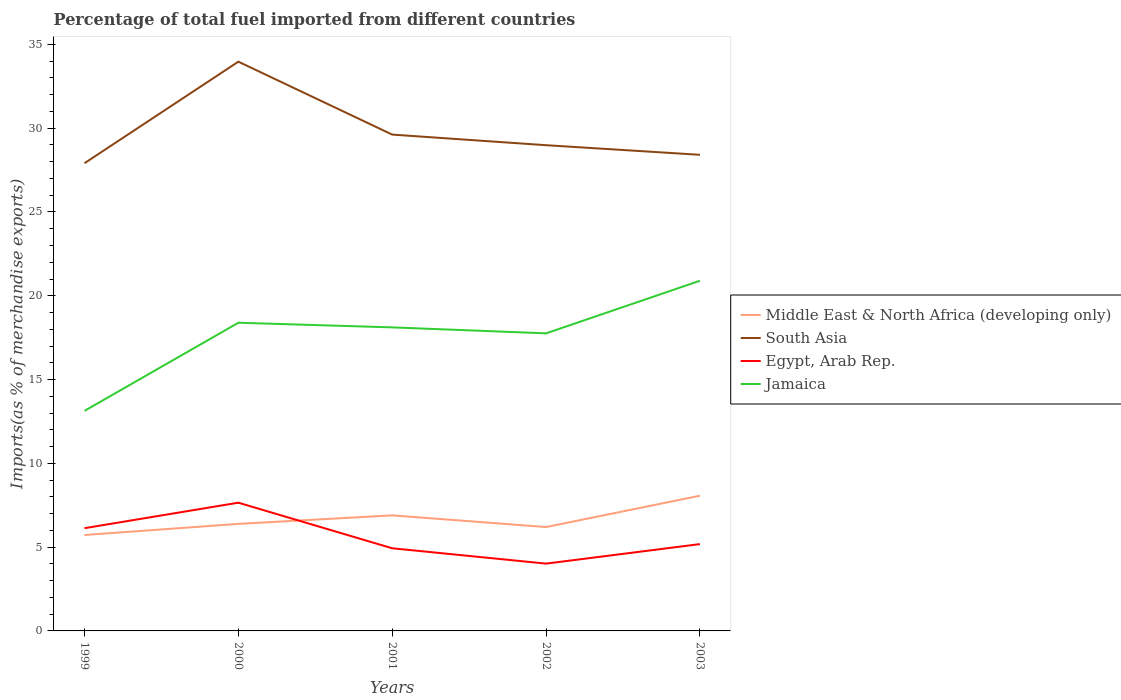How many different coloured lines are there?
Offer a very short reply. 4. Does the line corresponding to Egypt, Arab Rep. intersect with the line corresponding to Middle East & North Africa (developing only)?
Offer a terse response. Yes. Is the number of lines equal to the number of legend labels?
Your answer should be very brief. Yes. Across all years, what is the maximum percentage of imports to different countries in South Asia?
Offer a very short reply. 27.91. In which year was the percentage of imports to different countries in Egypt, Arab Rep. maximum?
Your response must be concise. 2002. What is the total percentage of imports to different countries in Egypt, Arab Rep. in the graph?
Provide a succinct answer. 2.47. What is the difference between the highest and the second highest percentage of imports to different countries in Egypt, Arab Rep.?
Make the answer very short. 3.64. How many years are there in the graph?
Your answer should be very brief. 5. Are the values on the major ticks of Y-axis written in scientific E-notation?
Provide a short and direct response. No. Does the graph contain grids?
Offer a terse response. No. How are the legend labels stacked?
Ensure brevity in your answer.  Vertical. What is the title of the graph?
Make the answer very short. Percentage of total fuel imported from different countries. Does "Hungary" appear as one of the legend labels in the graph?
Keep it short and to the point. No. What is the label or title of the Y-axis?
Your answer should be compact. Imports(as % of merchandise exports). What is the Imports(as % of merchandise exports) in Middle East & North Africa (developing only) in 1999?
Offer a terse response. 5.72. What is the Imports(as % of merchandise exports) of South Asia in 1999?
Offer a very short reply. 27.91. What is the Imports(as % of merchandise exports) in Egypt, Arab Rep. in 1999?
Keep it short and to the point. 6.13. What is the Imports(as % of merchandise exports) of Jamaica in 1999?
Provide a short and direct response. 13.13. What is the Imports(as % of merchandise exports) of Middle East & North Africa (developing only) in 2000?
Make the answer very short. 6.39. What is the Imports(as % of merchandise exports) in South Asia in 2000?
Your answer should be compact. 33.97. What is the Imports(as % of merchandise exports) in Egypt, Arab Rep. in 2000?
Your answer should be compact. 7.65. What is the Imports(as % of merchandise exports) in Jamaica in 2000?
Offer a very short reply. 18.39. What is the Imports(as % of merchandise exports) in Middle East & North Africa (developing only) in 2001?
Make the answer very short. 6.9. What is the Imports(as % of merchandise exports) in South Asia in 2001?
Offer a very short reply. 29.62. What is the Imports(as % of merchandise exports) of Egypt, Arab Rep. in 2001?
Your response must be concise. 4.93. What is the Imports(as % of merchandise exports) in Jamaica in 2001?
Ensure brevity in your answer.  18.11. What is the Imports(as % of merchandise exports) in Middle East & North Africa (developing only) in 2002?
Your response must be concise. 6.2. What is the Imports(as % of merchandise exports) in South Asia in 2002?
Give a very brief answer. 28.99. What is the Imports(as % of merchandise exports) in Egypt, Arab Rep. in 2002?
Your answer should be compact. 4.02. What is the Imports(as % of merchandise exports) of Jamaica in 2002?
Offer a terse response. 17.76. What is the Imports(as % of merchandise exports) in Middle East & North Africa (developing only) in 2003?
Ensure brevity in your answer.  8.07. What is the Imports(as % of merchandise exports) in South Asia in 2003?
Keep it short and to the point. 28.41. What is the Imports(as % of merchandise exports) of Egypt, Arab Rep. in 2003?
Make the answer very short. 5.18. What is the Imports(as % of merchandise exports) in Jamaica in 2003?
Make the answer very short. 20.9. Across all years, what is the maximum Imports(as % of merchandise exports) in Middle East & North Africa (developing only)?
Provide a succinct answer. 8.07. Across all years, what is the maximum Imports(as % of merchandise exports) in South Asia?
Provide a succinct answer. 33.97. Across all years, what is the maximum Imports(as % of merchandise exports) of Egypt, Arab Rep.?
Your answer should be compact. 7.65. Across all years, what is the maximum Imports(as % of merchandise exports) in Jamaica?
Keep it short and to the point. 20.9. Across all years, what is the minimum Imports(as % of merchandise exports) in Middle East & North Africa (developing only)?
Make the answer very short. 5.72. Across all years, what is the minimum Imports(as % of merchandise exports) in South Asia?
Make the answer very short. 27.91. Across all years, what is the minimum Imports(as % of merchandise exports) in Egypt, Arab Rep.?
Provide a succinct answer. 4.02. Across all years, what is the minimum Imports(as % of merchandise exports) of Jamaica?
Your answer should be very brief. 13.13. What is the total Imports(as % of merchandise exports) of Middle East & North Africa (developing only) in the graph?
Your answer should be compact. 33.28. What is the total Imports(as % of merchandise exports) of South Asia in the graph?
Your answer should be very brief. 148.9. What is the total Imports(as % of merchandise exports) of Egypt, Arab Rep. in the graph?
Ensure brevity in your answer.  27.91. What is the total Imports(as % of merchandise exports) of Jamaica in the graph?
Provide a succinct answer. 88.29. What is the difference between the Imports(as % of merchandise exports) in Middle East & North Africa (developing only) in 1999 and that in 2000?
Offer a terse response. -0.66. What is the difference between the Imports(as % of merchandise exports) of South Asia in 1999 and that in 2000?
Ensure brevity in your answer.  -6.06. What is the difference between the Imports(as % of merchandise exports) of Egypt, Arab Rep. in 1999 and that in 2000?
Your response must be concise. -1.52. What is the difference between the Imports(as % of merchandise exports) in Jamaica in 1999 and that in 2000?
Give a very brief answer. -5.26. What is the difference between the Imports(as % of merchandise exports) of Middle East & North Africa (developing only) in 1999 and that in 2001?
Your answer should be very brief. -1.17. What is the difference between the Imports(as % of merchandise exports) of South Asia in 1999 and that in 2001?
Your answer should be compact. -1.71. What is the difference between the Imports(as % of merchandise exports) of Egypt, Arab Rep. in 1999 and that in 2001?
Make the answer very short. 1.2. What is the difference between the Imports(as % of merchandise exports) of Jamaica in 1999 and that in 2001?
Your response must be concise. -4.98. What is the difference between the Imports(as % of merchandise exports) of Middle East & North Africa (developing only) in 1999 and that in 2002?
Provide a short and direct response. -0.48. What is the difference between the Imports(as % of merchandise exports) in South Asia in 1999 and that in 2002?
Provide a short and direct response. -1.08. What is the difference between the Imports(as % of merchandise exports) of Egypt, Arab Rep. in 1999 and that in 2002?
Give a very brief answer. 2.11. What is the difference between the Imports(as % of merchandise exports) in Jamaica in 1999 and that in 2002?
Your answer should be compact. -4.63. What is the difference between the Imports(as % of merchandise exports) of Middle East & North Africa (developing only) in 1999 and that in 2003?
Keep it short and to the point. -2.35. What is the difference between the Imports(as % of merchandise exports) of South Asia in 1999 and that in 2003?
Ensure brevity in your answer.  -0.5. What is the difference between the Imports(as % of merchandise exports) in Egypt, Arab Rep. in 1999 and that in 2003?
Provide a succinct answer. 0.95. What is the difference between the Imports(as % of merchandise exports) of Jamaica in 1999 and that in 2003?
Your answer should be very brief. -7.76. What is the difference between the Imports(as % of merchandise exports) of Middle East & North Africa (developing only) in 2000 and that in 2001?
Keep it short and to the point. -0.51. What is the difference between the Imports(as % of merchandise exports) of South Asia in 2000 and that in 2001?
Offer a terse response. 4.35. What is the difference between the Imports(as % of merchandise exports) in Egypt, Arab Rep. in 2000 and that in 2001?
Provide a short and direct response. 2.72. What is the difference between the Imports(as % of merchandise exports) of Jamaica in 2000 and that in 2001?
Make the answer very short. 0.28. What is the difference between the Imports(as % of merchandise exports) in Middle East & North Africa (developing only) in 2000 and that in 2002?
Give a very brief answer. 0.19. What is the difference between the Imports(as % of merchandise exports) of South Asia in 2000 and that in 2002?
Offer a terse response. 4.98. What is the difference between the Imports(as % of merchandise exports) in Egypt, Arab Rep. in 2000 and that in 2002?
Offer a terse response. 3.64. What is the difference between the Imports(as % of merchandise exports) of Jamaica in 2000 and that in 2002?
Your response must be concise. 0.63. What is the difference between the Imports(as % of merchandise exports) of Middle East & North Africa (developing only) in 2000 and that in 2003?
Make the answer very short. -1.68. What is the difference between the Imports(as % of merchandise exports) in South Asia in 2000 and that in 2003?
Make the answer very short. 5.56. What is the difference between the Imports(as % of merchandise exports) in Egypt, Arab Rep. in 2000 and that in 2003?
Your answer should be very brief. 2.47. What is the difference between the Imports(as % of merchandise exports) of Jamaica in 2000 and that in 2003?
Provide a succinct answer. -2.51. What is the difference between the Imports(as % of merchandise exports) in Middle East & North Africa (developing only) in 2001 and that in 2002?
Offer a very short reply. 0.7. What is the difference between the Imports(as % of merchandise exports) in South Asia in 2001 and that in 2002?
Give a very brief answer. 0.63. What is the difference between the Imports(as % of merchandise exports) of Egypt, Arab Rep. in 2001 and that in 2002?
Provide a succinct answer. 0.92. What is the difference between the Imports(as % of merchandise exports) in Jamaica in 2001 and that in 2002?
Make the answer very short. 0.36. What is the difference between the Imports(as % of merchandise exports) in Middle East & North Africa (developing only) in 2001 and that in 2003?
Provide a short and direct response. -1.17. What is the difference between the Imports(as % of merchandise exports) of South Asia in 2001 and that in 2003?
Your answer should be compact. 1.21. What is the difference between the Imports(as % of merchandise exports) of Egypt, Arab Rep. in 2001 and that in 2003?
Keep it short and to the point. -0.25. What is the difference between the Imports(as % of merchandise exports) of Jamaica in 2001 and that in 2003?
Provide a succinct answer. -2.78. What is the difference between the Imports(as % of merchandise exports) of Middle East & North Africa (developing only) in 2002 and that in 2003?
Provide a succinct answer. -1.87. What is the difference between the Imports(as % of merchandise exports) of South Asia in 2002 and that in 2003?
Your answer should be compact. 0.57. What is the difference between the Imports(as % of merchandise exports) in Egypt, Arab Rep. in 2002 and that in 2003?
Your response must be concise. -1.16. What is the difference between the Imports(as % of merchandise exports) in Jamaica in 2002 and that in 2003?
Your response must be concise. -3.14. What is the difference between the Imports(as % of merchandise exports) in Middle East & North Africa (developing only) in 1999 and the Imports(as % of merchandise exports) in South Asia in 2000?
Ensure brevity in your answer.  -28.25. What is the difference between the Imports(as % of merchandise exports) in Middle East & North Africa (developing only) in 1999 and the Imports(as % of merchandise exports) in Egypt, Arab Rep. in 2000?
Give a very brief answer. -1.93. What is the difference between the Imports(as % of merchandise exports) in Middle East & North Africa (developing only) in 1999 and the Imports(as % of merchandise exports) in Jamaica in 2000?
Give a very brief answer. -12.67. What is the difference between the Imports(as % of merchandise exports) of South Asia in 1999 and the Imports(as % of merchandise exports) of Egypt, Arab Rep. in 2000?
Make the answer very short. 20.26. What is the difference between the Imports(as % of merchandise exports) in South Asia in 1999 and the Imports(as % of merchandise exports) in Jamaica in 2000?
Your response must be concise. 9.52. What is the difference between the Imports(as % of merchandise exports) in Egypt, Arab Rep. in 1999 and the Imports(as % of merchandise exports) in Jamaica in 2000?
Your response must be concise. -12.26. What is the difference between the Imports(as % of merchandise exports) in Middle East & North Africa (developing only) in 1999 and the Imports(as % of merchandise exports) in South Asia in 2001?
Provide a short and direct response. -23.9. What is the difference between the Imports(as % of merchandise exports) in Middle East & North Africa (developing only) in 1999 and the Imports(as % of merchandise exports) in Egypt, Arab Rep. in 2001?
Keep it short and to the point. 0.79. What is the difference between the Imports(as % of merchandise exports) in Middle East & North Africa (developing only) in 1999 and the Imports(as % of merchandise exports) in Jamaica in 2001?
Provide a succinct answer. -12.39. What is the difference between the Imports(as % of merchandise exports) in South Asia in 1999 and the Imports(as % of merchandise exports) in Egypt, Arab Rep. in 2001?
Provide a short and direct response. 22.98. What is the difference between the Imports(as % of merchandise exports) of South Asia in 1999 and the Imports(as % of merchandise exports) of Jamaica in 2001?
Keep it short and to the point. 9.8. What is the difference between the Imports(as % of merchandise exports) of Egypt, Arab Rep. in 1999 and the Imports(as % of merchandise exports) of Jamaica in 2001?
Provide a short and direct response. -11.98. What is the difference between the Imports(as % of merchandise exports) of Middle East & North Africa (developing only) in 1999 and the Imports(as % of merchandise exports) of South Asia in 2002?
Your response must be concise. -23.26. What is the difference between the Imports(as % of merchandise exports) in Middle East & North Africa (developing only) in 1999 and the Imports(as % of merchandise exports) in Egypt, Arab Rep. in 2002?
Your response must be concise. 1.71. What is the difference between the Imports(as % of merchandise exports) in Middle East & North Africa (developing only) in 1999 and the Imports(as % of merchandise exports) in Jamaica in 2002?
Your answer should be compact. -12.03. What is the difference between the Imports(as % of merchandise exports) of South Asia in 1999 and the Imports(as % of merchandise exports) of Egypt, Arab Rep. in 2002?
Offer a very short reply. 23.89. What is the difference between the Imports(as % of merchandise exports) in South Asia in 1999 and the Imports(as % of merchandise exports) in Jamaica in 2002?
Provide a short and direct response. 10.15. What is the difference between the Imports(as % of merchandise exports) in Egypt, Arab Rep. in 1999 and the Imports(as % of merchandise exports) in Jamaica in 2002?
Your response must be concise. -11.63. What is the difference between the Imports(as % of merchandise exports) in Middle East & North Africa (developing only) in 1999 and the Imports(as % of merchandise exports) in South Asia in 2003?
Ensure brevity in your answer.  -22.69. What is the difference between the Imports(as % of merchandise exports) of Middle East & North Africa (developing only) in 1999 and the Imports(as % of merchandise exports) of Egypt, Arab Rep. in 2003?
Make the answer very short. 0.54. What is the difference between the Imports(as % of merchandise exports) in Middle East & North Africa (developing only) in 1999 and the Imports(as % of merchandise exports) in Jamaica in 2003?
Offer a very short reply. -15.17. What is the difference between the Imports(as % of merchandise exports) of South Asia in 1999 and the Imports(as % of merchandise exports) of Egypt, Arab Rep. in 2003?
Your response must be concise. 22.73. What is the difference between the Imports(as % of merchandise exports) in South Asia in 1999 and the Imports(as % of merchandise exports) in Jamaica in 2003?
Offer a very short reply. 7.01. What is the difference between the Imports(as % of merchandise exports) of Egypt, Arab Rep. in 1999 and the Imports(as % of merchandise exports) of Jamaica in 2003?
Your answer should be compact. -14.77. What is the difference between the Imports(as % of merchandise exports) of Middle East & North Africa (developing only) in 2000 and the Imports(as % of merchandise exports) of South Asia in 2001?
Offer a very short reply. -23.23. What is the difference between the Imports(as % of merchandise exports) in Middle East & North Africa (developing only) in 2000 and the Imports(as % of merchandise exports) in Egypt, Arab Rep. in 2001?
Provide a succinct answer. 1.46. What is the difference between the Imports(as % of merchandise exports) in Middle East & North Africa (developing only) in 2000 and the Imports(as % of merchandise exports) in Jamaica in 2001?
Give a very brief answer. -11.73. What is the difference between the Imports(as % of merchandise exports) of South Asia in 2000 and the Imports(as % of merchandise exports) of Egypt, Arab Rep. in 2001?
Offer a terse response. 29.04. What is the difference between the Imports(as % of merchandise exports) of South Asia in 2000 and the Imports(as % of merchandise exports) of Jamaica in 2001?
Your response must be concise. 15.86. What is the difference between the Imports(as % of merchandise exports) in Egypt, Arab Rep. in 2000 and the Imports(as % of merchandise exports) in Jamaica in 2001?
Your answer should be very brief. -10.46. What is the difference between the Imports(as % of merchandise exports) in Middle East & North Africa (developing only) in 2000 and the Imports(as % of merchandise exports) in South Asia in 2002?
Ensure brevity in your answer.  -22.6. What is the difference between the Imports(as % of merchandise exports) of Middle East & North Africa (developing only) in 2000 and the Imports(as % of merchandise exports) of Egypt, Arab Rep. in 2002?
Offer a very short reply. 2.37. What is the difference between the Imports(as % of merchandise exports) of Middle East & North Africa (developing only) in 2000 and the Imports(as % of merchandise exports) of Jamaica in 2002?
Make the answer very short. -11.37. What is the difference between the Imports(as % of merchandise exports) of South Asia in 2000 and the Imports(as % of merchandise exports) of Egypt, Arab Rep. in 2002?
Give a very brief answer. 29.95. What is the difference between the Imports(as % of merchandise exports) in South Asia in 2000 and the Imports(as % of merchandise exports) in Jamaica in 2002?
Offer a terse response. 16.21. What is the difference between the Imports(as % of merchandise exports) of Egypt, Arab Rep. in 2000 and the Imports(as % of merchandise exports) of Jamaica in 2002?
Your answer should be very brief. -10.11. What is the difference between the Imports(as % of merchandise exports) in Middle East & North Africa (developing only) in 2000 and the Imports(as % of merchandise exports) in South Asia in 2003?
Offer a very short reply. -22.02. What is the difference between the Imports(as % of merchandise exports) in Middle East & North Africa (developing only) in 2000 and the Imports(as % of merchandise exports) in Egypt, Arab Rep. in 2003?
Keep it short and to the point. 1.21. What is the difference between the Imports(as % of merchandise exports) in Middle East & North Africa (developing only) in 2000 and the Imports(as % of merchandise exports) in Jamaica in 2003?
Provide a short and direct response. -14.51. What is the difference between the Imports(as % of merchandise exports) of South Asia in 2000 and the Imports(as % of merchandise exports) of Egypt, Arab Rep. in 2003?
Keep it short and to the point. 28.79. What is the difference between the Imports(as % of merchandise exports) in South Asia in 2000 and the Imports(as % of merchandise exports) in Jamaica in 2003?
Your answer should be compact. 13.07. What is the difference between the Imports(as % of merchandise exports) of Egypt, Arab Rep. in 2000 and the Imports(as % of merchandise exports) of Jamaica in 2003?
Your response must be concise. -13.24. What is the difference between the Imports(as % of merchandise exports) of Middle East & North Africa (developing only) in 2001 and the Imports(as % of merchandise exports) of South Asia in 2002?
Offer a terse response. -22.09. What is the difference between the Imports(as % of merchandise exports) of Middle East & North Africa (developing only) in 2001 and the Imports(as % of merchandise exports) of Egypt, Arab Rep. in 2002?
Provide a short and direct response. 2.88. What is the difference between the Imports(as % of merchandise exports) in Middle East & North Africa (developing only) in 2001 and the Imports(as % of merchandise exports) in Jamaica in 2002?
Provide a succinct answer. -10.86. What is the difference between the Imports(as % of merchandise exports) of South Asia in 2001 and the Imports(as % of merchandise exports) of Egypt, Arab Rep. in 2002?
Offer a very short reply. 25.6. What is the difference between the Imports(as % of merchandise exports) in South Asia in 2001 and the Imports(as % of merchandise exports) in Jamaica in 2002?
Offer a very short reply. 11.86. What is the difference between the Imports(as % of merchandise exports) of Egypt, Arab Rep. in 2001 and the Imports(as % of merchandise exports) of Jamaica in 2002?
Provide a succinct answer. -12.83. What is the difference between the Imports(as % of merchandise exports) in Middle East & North Africa (developing only) in 2001 and the Imports(as % of merchandise exports) in South Asia in 2003?
Make the answer very short. -21.52. What is the difference between the Imports(as % of merchandise exports) of Middle East & North Africa (developing only) in 2001 and the Imports(as % of merchandise exports) of Egypt, Arab Rep. in 2003?
Provide a succinct answer. 1.72. What is the difference between the Imports(as % of merchandise exports) of Middle East & North Africa (developing only) in 2001 and the Imports(as % of merchandise exports) of Jamaica in 2003?
Ensure brevity in your answer.  -14. What is the difference between the Imports(as % of merchandise exports) in South Asia in 2001 and the Imports(as % of merchandise exports) in Egypt, Arab Rep. in 2003?
Provide a succinct answer. 24.44. What is the difference between the Imports(as % of merchandise exports) of South Asia in 2001 and the Imports(as % of merchandise exports) of Jamaica in 2003?
Make the answer very short. 8.72. What is the difference between the Imports(as % of merchandise exports) in Egypt, Arab Rep. in 2001 and the Imports(as % of merchandise exports) in Jamaica in 2003?
Your answer should be compact. -15.96. What is the difference between the Imports(as % of merchandise exports) in Middle East & North Africa (developing only) in 2002 and the Imports(as % of merchandise exports) in South Asia in 2003?
Offer a terse response. -22.21. What is the difference between the Imports(as % of merchandise exports) in Middle East & North Africa (developing only) in 2002 and the Imports(as % of merchandise exports) in Egypt, Arab Rep. in 2003?
Your answer should be compact. 1.02. What is the difference between the Imports(as % of merchandise exports) in Middle East & North Africa (developing only) in 2002 and the Imports(as % of merchandise exports) in Jamaica in 2003?
Ensure brevity in your answer.  -14.7. What is the difference between the Imports(as % of merchandise exports) of South Asia in 2002 and the Imports(as % of merchandise exports) of Egypt, Arab Rep. in 2003?
Give a very brief answer. 23.8. What is the difference between the Imports(as % of merchandise exports) of South Asia in 2002 and the Imports(as % of merchandise exports) of Jamaica in 2003?
Your answer should be compact. 8.09. What is the difference between the Imports(as % of merchandise exports) of Egypt, Arab Rep. in 2002 and the Imports(as % of merchandise exports) of Jamaica in 2003?
Provide a succinct answer. -16.88. What is the average Imports(as % of merchandise exports) of Middle East & North Africa (developing only) per year?
Make the answer very short. 6.66. What is the average Imports(as % of merchandise exports) in South Asia per year?
Ensure brevity in your answer.  29.78. What is the average Imports(as % of merchandise exports) of Egypt, Arab Rep. per year?
Keep it short and to the point. 5.58. What is the average Imports(as % of merchandise exports) of Jamaica per year?
Make the answer very short. 17.66. In the year 1999, what is the difference between the Imports(as % of merchandise exports) in Middle East & North Africa (developing only) and Imports(as % of merchandise exports) in South Asia?
Make the answer very short. -22.19. In the year 1999, what is the difference between the Imports(as % of merchandise exports) of Middle East & North Africa (developing only) and Imports(as % of merchandise exports) of Egypt, Arab Rep.?
Keep it short and to the point. -0.41. In the year 1999, what is the difference between the Imports(as % of merchandise exports) in Middle East & North Africa (developing only) and Imports(as % of merchandise exports) in Jamaica?
Give a very brief answer. -7.41. In the year 1999, what is the difference between the Imports(as % of merchandise exports) in South Asia and Imports(as % of merchandise exports) in Egypt, Arab Rep.?
Provide a short and direct response. 21.78. In the year 1999, what is the difference between the Imports(as % of merchandise exports) in South Asia and Imports(as % of merchandise exports) in Jamaica?
Your answer should be very brief. 14.78. In the year 1999, what is the difference between the Imports(as % of merchandise exports) of Egypt, Arab Rep. and Imports(as % of merchandise exports) of Jamaica?
Give a very brief answer. -7. In the year 2000, what is the difference between the Imports(as % of merchandise exports) of Middle East & North Africa (developing only) and Imports(as % of merchandise exports) of South Asia?
Provide a succinct answer. -27.58. In the year 2000, what is the difference between the Imports(as % of merchandise exports) of Middle East & North Africa (developing only) and Imports(as % of merchandise exports) of Egypt, Arab Rep.?
Your answer should be compact. -1.26. In the year 2000, what is the difference between the Imports(as % of merchandise exports) of Middle East & North Africa (developing only) and Imports(as % of merchandise exports) of Jamaica?
Make the answer very short. -12. In the year 2000, what is the difference between the Imports(as % of merchandise exports) in South Asia and Imports(as % of merchandise exports) in Egypt, Arab Rep.?
Your response must be concise. 26.32. In the year 2000, what is the difference between the Imports(as % of merchandise exports) of South Asia and Imports(as % of merchandise exports) of Jamaica?
Provide a short and direct response. 15.58. In the year 2000, what is the difference between the Imports(as % of merchandise exports) of Egypt, Arab Rep. and Imports(as % of merchandise exports) of Jamaica?
Your answer should be very brief. -10.74. In the year 2001, what is the difference between the Imports(as % of merchandise exports) in Middle East & North Africa (developing only) and Imports(as % of merchandise exports) in South Asia?
Your response must be concise. -22.72. In the year 2001, what is the difference between the Imports(as % of merchandise exports) in Middle East & North Africa (developing only) and Imports(as % of merchandise exports) in Egypt, Arab Rep.?
Offer a terse response. 1.96. In the year 2001, what is the difference between the Imports(as % of merchandise exports) in Middle East & North Africa (developing only) and Imports(as % of merchandise exports) in Jamaica?
Your answer should be very brief. -11.22. In the year 2001, what is the difference between the Imports(as % of merchandise exports) in South Asia and Imports(as % of merchandise exports) in Egypt, Arab Rep.?
Your response must be concise. 24.69. In the year 2001, what is the difference between the Imports(as % of merchandise exports) in South Asia and Imports(as % of merchandise exports) in Jamaica?
Give a very brief answer. 11.5. In the year 2001, what is the difference between the Imports(as % of merchandise exports) of Egypt, Arab Rep. and Imports(as % of merchandise exports) of Jamaica?
Ensure brevity in your answer.  -13.18. In the year 2002, what is the difference between the Imports(as % of merchandise exports) of Middle East & North Africa (developing only) and Imports(as % of merchandise exports) of South Asia?
Offer a very short reply. -22.79. In the year 2002, what is the difference between the Imports(as % of merchandise exports) in Middle East & North Africa (developing only) and Imports(as % of merchandise exports) in Egypt, Arab Rep.?
Your answer should be very brief. 2.18. In the year 2002, what is the difference between the Imports(as % of merchandise exports) of Middle East & North Africa (developing only) and Imports(as % of merchandise exports) of Jamaica?
Give a very brief answer. -11.56. In the year 2002, what is the difference between the Imports(as % of merchandise exports) in South Asia and Imports(as % of merchandise exports) in Egypt, Arab Rep.?
Make the answer very short. 24.97. In the year 2002, what is the difference between the Imports(as % of merchandise exports) in South Asia and Imports(as % of merchandise exports) in Jamaica?
Your answer should be compact. 11.23. In the year 2002, what is the difference between the Imports(as % of merchandise exports) of Egypt, Arab Rep. and Imports(as % of merchandise exports) of Jamaica?
Provide a short and direct response. -13.74. In the year 2003, what is the difference between the Imports(as % of merchandise exports) of Middle East & North Africa (developing only) and Imports(as % of merchandise exports) of South Asia?
Your response must be concise. -20.34. In the year 2003, what is the difference between the Imports(as % of merchandise exports) of Middle East & North Africa (developing only) and Imports(as % of merchandise exports) of Egypt, Arab Rep.?
Your answer should be very brief. 2.89. In the year 2003, what is the difference between the Imports(as % of merchandise exports) of Middle East & North Africa (developing only) and Imports(as % of merchandise exports) of Jamaica?
Provide a short and direct response. -12.83. In the year 2003, what is the difference between the Imports(as % of merchandise exports) of South Asia and Imports(as % of merchandise exports) of Egypt, Arab Rep.?
Your answer should be compact. 23.23. In the year 2003, what is the difference between the Imports(as % of merchandise exports) in South Asia and Imports(as % of merchandise exports) in Jamaica?
Provide a succinct answer. 7.52. In the year 2003, what is the difference between the Imports(as % of merchandise exports) in Egypt, Arab Rep. and Imports(as % of merchandise exports) in Jamaica?
Offer a terse response. -15.71. What is the ratio of the Imports(as % of merchandise exports) of Middle East & North Africa (developing only) in 1999 to that in 2000?
Offer a terse response. 0.9. What is the ratio of the Imports(as % of merchandise exports) in South Asia in 1999 to that in 2000?
Your answer should be compact. 0.82. What is the ratio of the Imports(as % of merchandise exports) in Egypt, Arab Rep. in 1999 to that in 2000?
Offer a terse response. 0.8. What is the ratio of the Imports(as % of merchandise exports) in Jamaica in 1999 to that in 2000?
Provide a succinct answer. 0.71. What is the ratio of the Imports(as % of merchandise exports) in Middle East & North Africa (developing only) in 1999 to that in 2001?
Provide a succinct answer. 0.83. What is the ratio of the Imports(as % of merchandise exports) of South Asia in 1999 to that in 2001?
Your answer should be compact. 0.94. What is the ratio of the Imports(as % of merchandise exports) in Egypt, Arab Rep. in 1999 to that in 2001?
Your answer should be very brief. 1.24. What is the ratio of the Imports(as % of merchandise exports) of Jamaica in 1999 to that in 2001?
Keep it short and to the point. 0.72. What is the ratio of the Imports(as % of merchandise exports) in Middle East & North Africa (developing only) in 1999 to that in 2002?
Provide a succinct answer. 0.92. What is the ratio of the Imports(as % of merchandise exports) in South Asia in 1999 to that in 2002?
Give a very brief answer. 0.96. What is the ratio of the Imports(as % of merchandise exports) of Egypt, Arab Rep. in 1999 to that in 2002?
Ensure brevity in your answer.  1.53. What is the ratio of the Imports(as % of merchandise exports) in Jamaica in 1999 to that in 2002?
Ensure brevity in your answer.  0.74. What is the ratio of the Imports(as % of merchandise exports) of Middle East & North Africa (developing only) in 1999 to that in 2003?
Your answer should be compact. 0.71. What is the ratio of the Imports(as % of merchandise exports) in South Asia in 1999 to that in 2003?
Your answer should be very brief. 0.98. What is the ratio of the Imports(as % of merchandise exports) in Egypt, Arab Rep. in 1999 to that in 2003?
Provide a short and direct response. 1.18. What is the ratio of the Imports(as % of merchandise exports) of Jamaica in 1999 to that in 2003?
Provide a succinct answer. 0.63. What is the ratio of the Imports(as % of merchandise exports) in Middle East & North Africa (developing only) in 2000 to that in 2001?
Ensure brevity in your answer.  0.93. What is the ratio of the Imports(as % of merchandise exports) in South Asia in 2000 to that in 2001?
Give a very brief answer. 1.15. What is the ratio of the Imports(as % of merchandise exports) in Egypt, Arab Rep. in 2000 to that in 2001?
Offer a very short reply. 1.55. What is the ratio of the Imports(as % of merchandise exports) of Jamaica in 2000 to that in 2001?
Offer a terse response. 1.02. What is the ratio of the Imports(as % of merchandise exports) of Middle East & North Africa (developing only) in 2000 to that in 2002?
Ensure brevity in your answer.  1.03. What is the ratio of the Imports(as % of merchandise exports) of South Asia in 2000 to that in 2002?
Offer a very short reply. 1.17. What is the ratio of the Imports(as % of merchandise exports) of Egypt, Arab Rep. in 2000 to that in 2002?
Your answer should be compact. 1.91. What is the ratio of the Imports(as % of merchandise exports) in Jamaica in 2000 to that in 2002?
Provide a succinct answer. 1.04. What is the ratio of the Imports(as % of merchandise exports) of Middle East & North Africa (developing only) in 2000 to that in 2003?
Ensure brevity in your answer.  0.79. What is the ratio of the Imports(as % of merchandise exports) of South Asia in 2000 to that in 2003?
Offer a very short reply. 1.2. What is the ratio of the Imports(as % of merchandise exports) of Egypt, Arab Rep. in 2000 to that in 2003?
Offer a terse response. 1.48. What is the ratio of the Imports(as % of merchandise exports) of Jamaica in 2000 to that in 2003?
Make the answer very short. 0.88. What is the ratio of the Imports(as % of merchandise exports) of Middle East & North Africa (developing only) in 2001 to that in 2002?
Give a very brief answer. 1.11. What is the ratio of the Imports(as % of merchandise exports) of South Asia in 2001 to that in 2002?
Make the answer very short. 1.02. What is the ratio of the Imports(as % of merchandise exports) in Egypt, Arab Rep. in 2001 to that in 2002?
Keep it short and to the point. 1.23. What is the ratio of the Imports(as % of merchandise exports) in Jamaica in 2001 to that in 2002?
Ensure brevity in your answer.  1.02. What is the ratio of the Imports(as % of merchandise exports) in Middle East & North Africa (developing only) in 2001 to that in 2003?
Keep it short and to the point. 0.85. What is the ratio of the Imports(as % of merchandise exports) of South Asia in 2001 to that in 2003?
Offer a terse response. 1.04. What is the ratio of the Imports(as % of merchandise exports) in Egypt, Arab Rep. in 2001 to that in 2003?
Offer a very short reply. 0.95. What is the ratio of the Imports(as % of merchandise exports) of Jamaica in 2001 to that in 2003?
Provide a short and direct response. 0.87. What is the ratio of the Imports(as % of merchandise exports) in Middle East & North Africa (developing only) in 2002 to that in 2003?
Your answer should be compact. 0.77. What is the ratio of the Imports(as % of merchandise exports) in South Asia in 2002 to that in 2003?
Keep it short and to the point. 1.02. What is the ratio of the Imports(as % of merchandise exports) of Egypt, Arab Rep. in 2002 to that in 2003?
Give a very brief answer. 0.78. What is the ratio of the Imports(as % of merchandise exports) of Jamaica in 2002 to that in 2003?
Offer a very short reply. 0.85. What is the difference between the highest and the second highest Imports(as % of merchandise exports) of Middle East & North Africa (developing only)?
Provide a short and direct response. 1.17. What is the difference between the highest and the second highest Imports(as % of merchandise exports) in South Asia?
Make the answer very short. 4.35. What is the difference between the highest and the second highest Imports(as % of merchandise exports) in Egypt, Arab Rep.?
Give a very brief answer. 1.52. What is the difference between the highest and the second highest Imports(as % of merchandise exports) in Jamaica?
Give a very brief answer. 2.51. What is the difference between the highest and the lowest Imports(as % of merchandise exports) of Middle East & North Africa (developing only)?
Your answer should be very brief. 2.35. What is the difference between the highest and the lowest Imports(as % of merchandise exports) of South Asia?
Provide a short and direct response. 6.06. What is the difference between the highest and the lowest Imports(as % of merchandise exports) in Egypt, Arab Rep.?
Provide a succinct answer. 3.64. What is the difference between the highest and the lowest Imports(as % of merchandise exports) of Jamaica?
Your response must be concise. 7.76. 